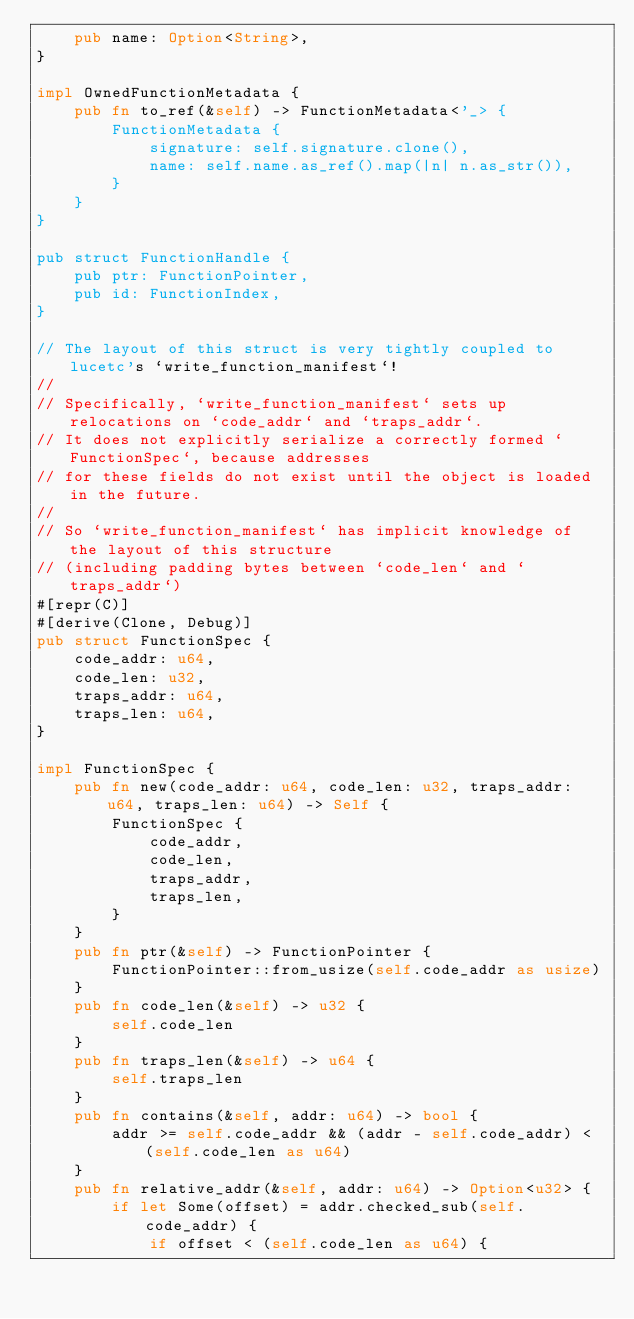<code> <loc_0><loc_0><loc_500><loc_500><_Rust_>    pub name: Option<String>,
}

impl OwnedFunctionMetadata {
    pub fn to_ref(&self) -> FunctionMetadata<'_> {
        FunctionMetadata {
            signature: self.signature.clone(),
            name: self.name.as_ref().map(|n| n.as_str()),
        }
    }
}

pub struct FunctionHandle {
    pub ptr: FunctionPointer,
    pub id: FunctionIndex,
}

// The layout of this struct is very tightly coupled to lucetc's `write_function_manifest`!
//
// Specifically, `write_function_manifest` sets up relocations on `code_addr` and `traps_addr`.
// It does not explicitly serialize a correctly formed `FunctionSpec`, because addresses
// for these fields do not exist until the object is loaded in the future.
//
// So `write_function_manifest` has implicit knowledge of the layout of this structure
// (including padding bytes between `code_len` and `traps_addr`)
#[repr(C)]
#[derive(Clone, Debug)]
pub struct FunctionSpec {
    code_addr: u64,
    code_len: u32,
    traps_addr: u64,
    traps_len: u64,
}

impl FunctionSpec {
    pub fn new(code_addr: u64, code_len: u32, traps_addr: u64, traps_len: u64) -> Self {
        FunctionSpec {
            code_addr,
            code_len,
            traps_addr,
            traps_len,
        }
    }
    pub fn ptr(&self) -> FunctionPointer {
        FunctionPointer::from_usize(self.code_addr as usize)
    }
    pub fn code_len(&self) -> u32 {
        self.code_len
    }
    pub fn traps_len(&self) -> u64 {
        self.traps_len
    }
    pub fn contains(&self, addr: u64) -> bool {
        addr >= self.code_addr && (addr - self.code_addr) < (self.code_len as u64)
    }
    pub fn relative_addr(&self, addr: u64) -> Option<u32> {
        if let Some(offset) = addr.checked_sub(self.code_addr) {
            if offset < (self.code_len as u64) {</code> 